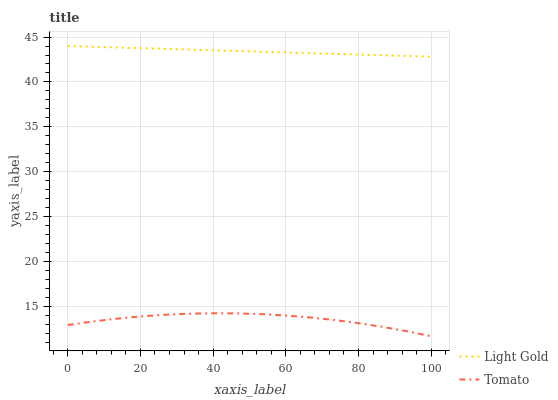Does Tomato have the minimum area under the curve?
Answer yes or no. Yes. Does Light Gold have the maximum area under the curve?
Answer yes or no. Yes. Does Light Gold have the minimum area under the curve?
Answer yes or no. No. Is Light Gold the smoothest?
Answer yes or no. Yes. Is Tomato the roughest?
Answer yes or no. Yes. Is Light Gold the roughest?
Answer yes or no. No. Does Tomato have the lowest value?
Answer yes or no. Yes. Does Light Gold have the lowest value?
Answer yes or no. No. Does Light Gold have the highest value?
Answer yes or no. Yes. Is Tomato less than Light Gold?
Answer yes or no. Yes. Is Light Gold greater than Tomato?
Answer yes or no. Yes. Does Tomato intersect Light Gold?
Answer yes or no. No. 